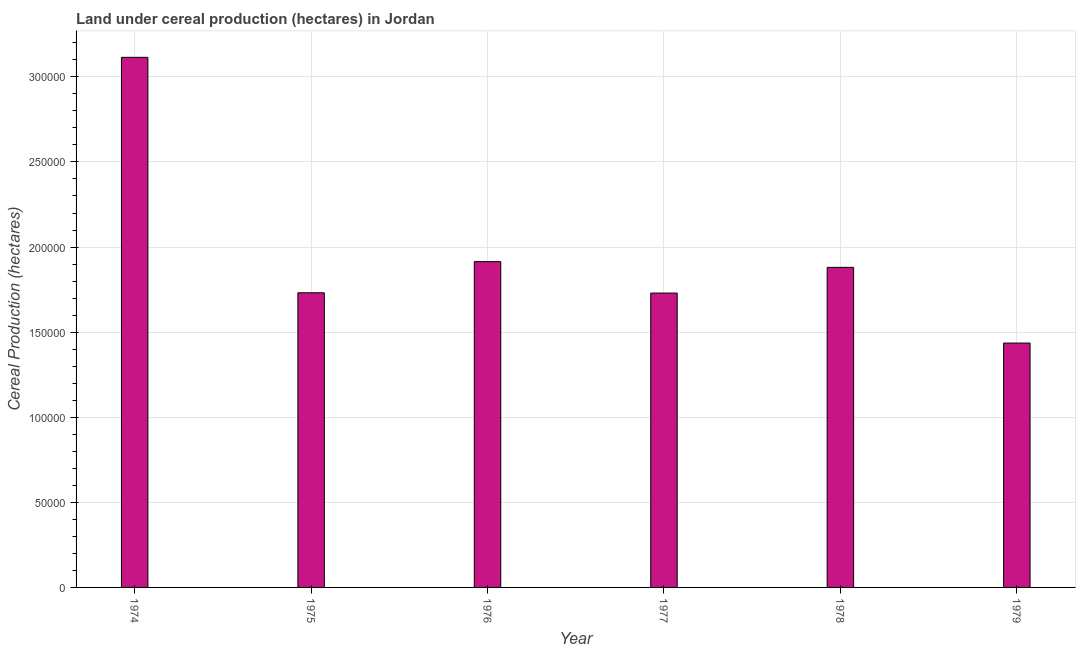Does the graph contain any zero values?
Provide a succinct answer. No. Does the graph contain grids?
Offer a terse response. Yes. What is the title of the graph?
Provide a succinct answer. Land under cereal production (hectares) in Jordan. What is the label or title of the Y-axis?
Provide a short and direct response. Cereal Production (hectares). What is the land under cereal production in 1976?
Keep it short and to the point. 1.91e+05. Across all years, what is the maximum land under cereal production?
Keep it short and to the point. 3.11e+05. Across all years, what is the minimum land under cereal production?
Your answer should be very brief. 1.44e+05. In which year was the land under cereal production maximum?
Keep it short and to the point. 1974. In which year was the land under cereal production minimum?
Provide a succinct answer. 1979. What is the sum of the land under cereal production?
Make the answer very short. 1.18e+06. What is the difference between the land under cereal production in 1977 and 1979?
Your answer should be very brief. 2.94e+04. What is the average land under cereal production per year?
Provide a succinct answer. 1.97e+05. What is the median land under cereal production?
Make the answer very short. 1.81e+05. Do a majority of the years between 1976 and 1978 (inclusive) have land under cereal production greater than 70000 hectares?
Give a very brief answer. Yes. What is the ratio of the land under cereal production in 1974 to that in 1976?
Keep it short and to the point. 1.63. What is the difference between the highest and the second highest land under cereal production?
Ensure brevity in your answer.  1.20e+05. Is the sum of the land under cereal production in 1974 and 1975 greater than the maximum land under cereal production across all years?
Offer a very short reply. Yes. What is the difference between the highest and the lowest land under cereal production?
Offer a very short reply. 1.68e+05. How many bars are there?
Provide a short and direct response. 6. What is the difference between two consecutive major ticks on the Y-axis?
Offer a very short reply. 5.00e+04. What is the Cereal Production (hectares) of 1974?
Make the answer very short. 3.11e+05. What is the Cereal Production (hectares) in 1975?
Your answer should be compact. 1.73e+05. What is the Cereal Production (hectares) of 1976?
Provide a short and direct response. 1.91e+05. What is the Cereal Production (hectares) of 1977?
Provide a succinct answer. 1.73e+05. What is the Cereal Production (hectares) in 1978?
Provide a succinct answer. 1.88e+05. What is the Cereal Production (hectares) of 1979?
Your answer should be compact. 1.44e+05. What is the difference between the Cereal Production (hectares) in 1974 and 1975?
Your answer should be compact. 1.38e+05. What is the difference between the Cereal Production (hectares) in 1974 and 1976?
Your response must be concise. 1.20e+05. What is the difference between the Cereal Production (hectares) in 1974 and 1977?
Your answer should be very brief. 1.39e+05. What is the difference between the Cereal Production (hectares) in 1974 and 1978?
Offer a very short reply. 1.23e+05. What is the difference between the Cereal Production (hectares) in 1974 and 1979?
Offer a very short reply. 1.68e+05. What is the difference between the Cereal Production (hectares) in 1975 and 1976?
Offer a very short reply. -1.83e+04. What is the difference between the Cereal Production (hectares) in 1975 and 1977?
Provide a short and direct response. 163. What is the difference between the Cereal Production (hectares) in 1975 and 1978?
Ensure brevity in your answer.  -1.49e+04. What is the difference between the Cereal Production (hectares) in 1975 and 1979?
Ensure brevity in your answer.  2.95e+04. What is the difference between the Cereal Production (hectares) in 1976 and 1977?
Your answer should be compact. 1.85e+04. What is the difference between the Cereal Production (hectares) in 1976 and 1978?
Your response must be concise. 3368. What is the difference between the Cereal Production (hectares) in 1976 and 1979?
Give a very brief answer. 4.78e+04. What is the difference between the Cereal Production (hectares) in 1977 and 1978?
Keep it short and to the point. -1.51e+04. What is the difference between the Cereal Production (hectares) in 1977 and 1979?
Make the answer very short. 2.94e+04. What is the difference between the Cereal Production (hectares) in 1978 and 1979?
Offer a terse response. 4.45e+04. What is the ratio of the Cereal Production (hectares) in 1974 to that in 1975?
Make the answer very short. 1.8. What is the ratio of the Cereal Production (hectares) in 1974 to that in 1976?
Your answer should be compact. 1.63. What is the ratio of the Cereal Production (hectares) in 1974 to that in 1977?
Your answer should be very brief. 1.8. What is the ratio of the Cereal Production (hectares) in 1974 to that in 1978?
Offer a very short reply. 1.66. What is the ratio of the Cereal Production (hectares) in 1974 to that in 1979?
Provide a succinct answer. 2.17. What is the ratio of the Cereal Production (hectares) in 1975 to that in 1976?
Your answer should be compact. 0.9. What is the ratio of the Cereal Production (hectares) in 1975 to that in 1978?
Your response must be concise. 0.92. What is the ratio of the Cereal Production (hectares) in 1975 to that in 1979?
Your response must be concise. 1.21. What is the ratio of the Cereal Production (hectares) in 1976 to that in 1977?
Your answer should be very brief. 1.11. What is the ratio of the Cereal Production (hectares) in 1976 to that in 1978?
Your answer should be very brief. 1.02. What is the ratio of the Cereal Production (hectares) in 1976 to that in 1979?
Keep it short and to the point. 1.33. What is the ratio of the Cereal Production (hectares) in 1977 to that in 1978?
Offer a terse response. 0.92. What is the ratio of the Cereal Production (hectares) in 1977 to that in 1979?
Offer a terse response. 1.21. What is the ratio of the Cereal Production (hectares) in 1978 to that in 1979?
Your answer should be very brief. 1.31. 